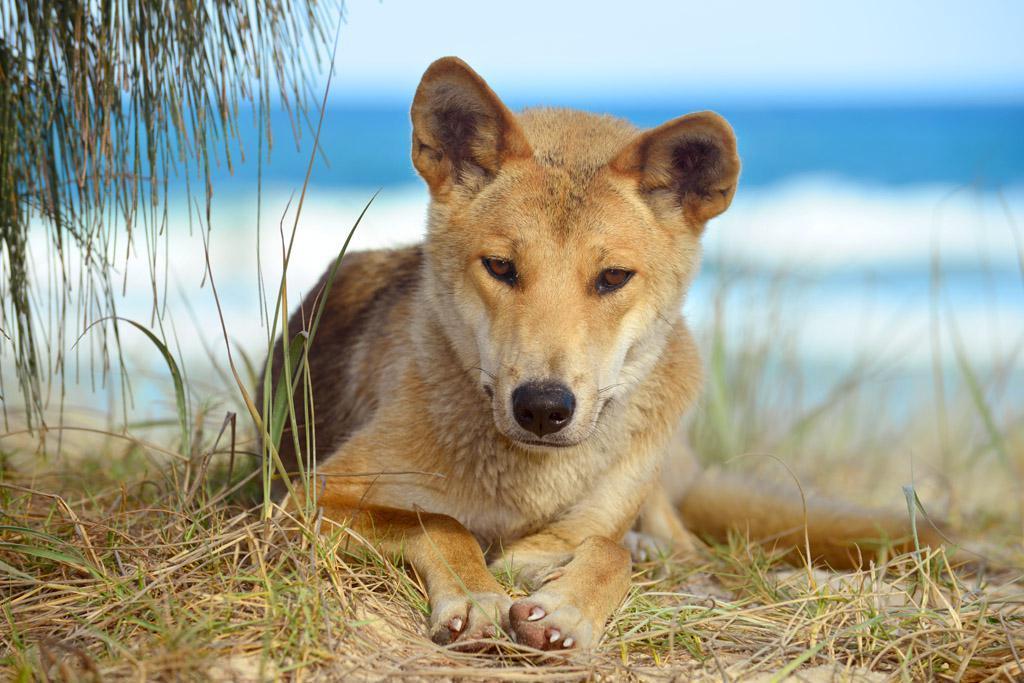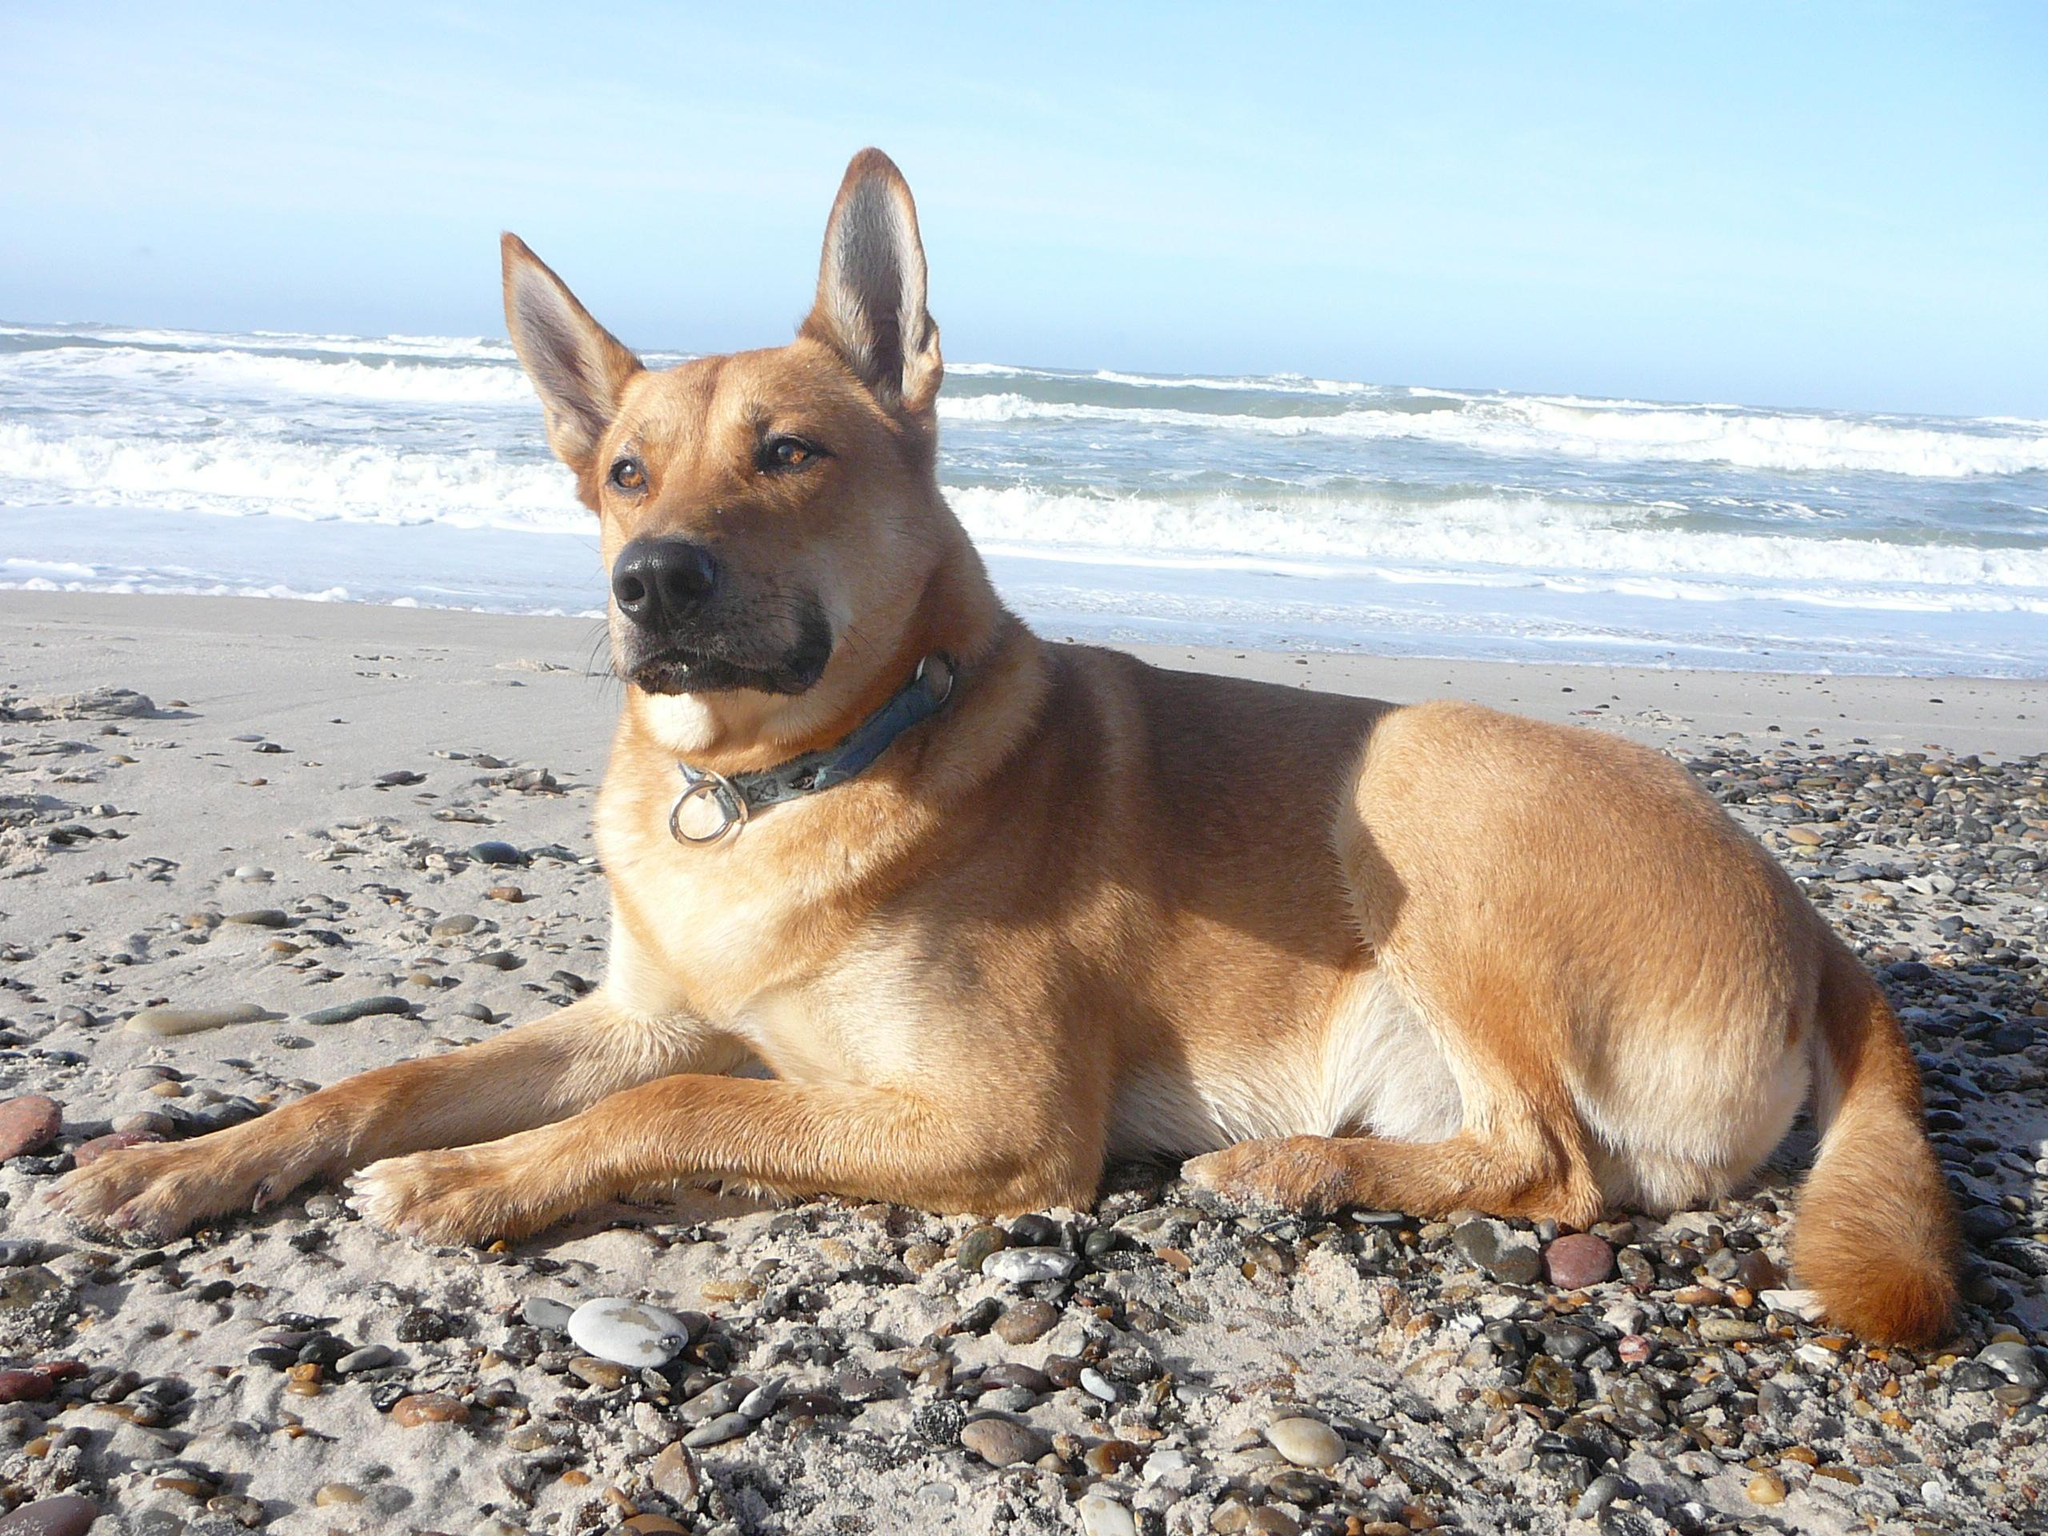The first image is the image on the left, the second image is the image on the right. Considering the images on both sides, is "In at least one of the images, there is a large body of water in the background." valid? Answer yes or no. Yes. The first image is the image on the left, the second image is the image on the right. For the images displayed, is the sentence "At least one of the dogs is in front of a large body of water." factually correct? Answer yes or no. Yes. 